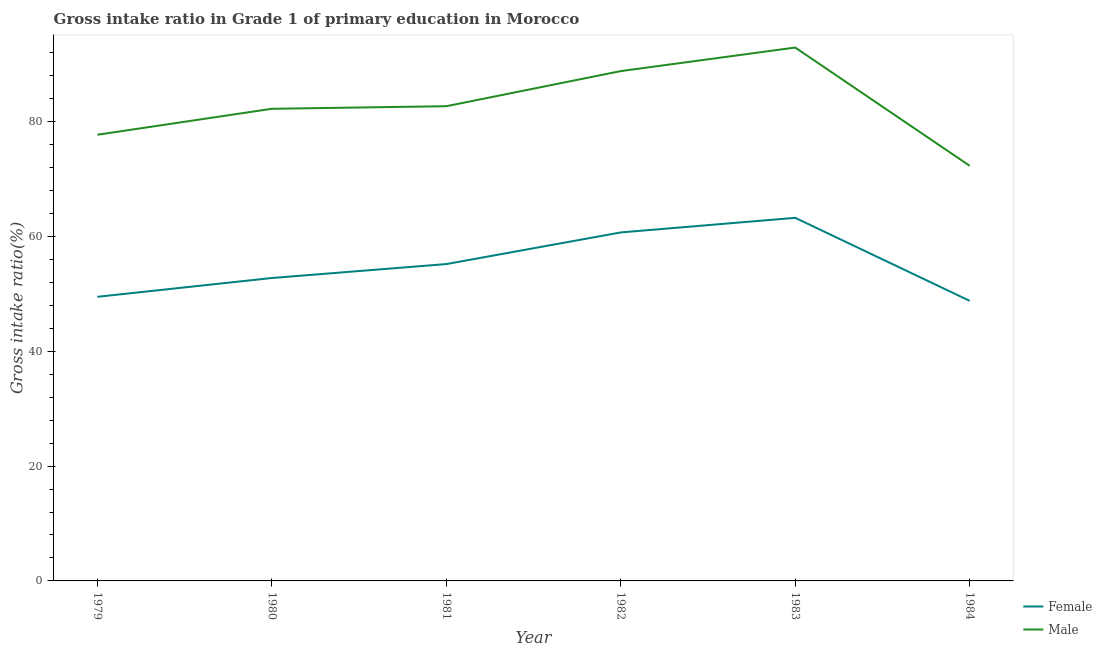Does the line corresponding to gross intake ratio(female) intersect with the line corresponding to gross intake ratio(male)?
Ensure brevity in your answer.  No. Is the number of lines equal to the number of legend labels?
Your answer should be very brief. Yes. What is the gross intake ratio(male) in 1983?
Provide a succinct answer. 92.88. Across all years, what is the maximum gross intake ratio(female)?
Make the answer very short. 63.23. Across all years, what is the minimum gross intake ratio(male)?
Your answer should be very brief. 72.29. In which year was the gross intake ratio(male) maximum?
Ensure brevity in your answer.  1983. In which year was the gross intake ratio(female) minimum?
Make the answer very short. 1984. What is the total gross intake ratio(male) in the graph?
Offer a terse response. 496.53. What is the difference between the gross intake ratio(female) in 1979 and that in 1981?
Your response must be concise. -5.7. What is the difference between the gross intake ratio(female) in 1981 and the gross intake ratio(male) in 1982?
Make the answer very short. -33.6. What is the average gross intake ratio(male) per year?
Provide a short and direct response. 82.76. In the year 1979, what is the difference between the gross intake ratio(female) and gross intake ratio(male)?
Offer a very short reply. -28.22. What is the ratio of the gross intake ratio(male) in 1979 to that in 1981?
Keep it short and to the point. 0.94. Is the difference between the gross intake ratio(male) in 1982 and 1984 greater than the difference between the gross intake ratio(female) in 1982 and 1984?
Your answer should be compact. Yes. What is the difference between the highest and the second highest gross intake ratio(female)?
Your answer should be very brief. 2.54. What is the difference between the highest and the lowest gross intake ratio(female)?
Offer a very short reply. 14.46. Does the gross intake ratio(female) monotonically increase over the years?
Offer a very short reply. No. Is the gross intake ratio(male) strictly greater than the gross intake ratio(female) over the years?
Offer a terse response. Yes. How many lines are there?
Your answer should be compact. 2. How many years are there in the graph?
Provide a short and direct response. 6. Are the values on the major ticks of Y-axis written in scientific E-notation?
Your answer should be compact. No. Does the graph contain any zero values?
Make the answer very short. No. Does the graph contain grids?
Offer a very short reply. No. Where does the legend appear in the graph?
Offer a terse response. Bottom right. How many legend labels are there?
Your response must be concise. 2. How are the legend labels stacked?
Offer a very short reply. Vertical. What is the title of the graph?
Offer a very short reply. Gross intake ratio in Grade 1 of primary education in Morocco. Does "% of gross capital formation" appear as one of the legend labels in the graph?
Provide a succinct answer. No. What is the label or title of the X-axis?
Offer a very short reply. Year. What is the label or title of the Y-axis?
Offer a terse response. Gross intake ratio(%). What is the Gross intake ratio(%) in Female in 1979?
Ensure brevity in your answer.  49.48. What is the Gross intake ratio(%) in Male in 1979?
Keep it short and to the point. 77.7. What is the Gross intake ratio(%) in Female in 1980?
Give a very brief answer. 52.75. What is the Gross intake ratio(%) of Male in 1980?
Give a very brief answer. 82.22. What is the Gross intake ratio(%) in Female in 1981?
Offer a terse response. 55.18. What is the Gross intake ratio(%) in Male in 1981?
Keep it short and to the point. 82.67. What is the Gross intake ratio(%) in Female in 1982?
Your answer should be very brief. 60.69. What is the Gross intake ratio(%) in Male in 1982?
Your answer should be compact. 88.78. What is the Gross intake ratio(%) in Female in 1983?
Your response must be concise. 63.23. What is the Gross intake ratio(%) in Male in 1983?
Keep it short and to the point. 92.88. What is the Gross intake ratio(%) in Female in 1984?
Ensure brevity in your answer.  48.77. What is the Gross intake ratio(%) of Male in 1984?
Offer a very short reply. 72.29. Across all years, what is the maximum Gross intake ratio(%) of Female?
Provide a succinct answer. 63.23. Across all years, what is the maximum Gross intake ratio(%) in Male?
Give a very brief answer. 92.88. Across all years, what is the minimum Gross intake ratio(%) of Female?
Provide a succinct answer. 48.77. Across all years, what is the minimum Gross intake ratio(%) in Male?
Provide a succinct answer. 72.29. What is the total Gross intake ratio(%) in Female in the graph?
Provide a short and direct response. 330.09. What is the total Gross intake ratio(%) in Male in the graph?
Provide a succinct answer. 496.53. What is the difference between the Gross intake ratio(%) in Female in 1979 and that in 1980?
Offer a very short reply. -3.27. What is the difference between the Gross intake ratio(%) of Male in 1979 and that in 1980?
Ensure brevity in your answer.  -4.52. What is the difference between the Gross intake ratio(%) of Female in 1979 and that in 1981?
Keep it short and to the point. -5.7. What is the difference between the Gross intake ratio(%) in Male in 1979 and that in 1981?
Your response must be concise. -4.97. What is the difference between the Gross intake ratio(%) of Female in 1979 and that in 1982?
Your answer should be very brief. -11.21. What is the difference between the Gross intake ratio(%) in Male in 1979 and that in 1982?
Your answer should be compact. -11.09. What is the difference between the Gross intake ratio(%) of Female in 1979 and that in 1983?
Provide a succinct answer. -13.75. What is the difference between the Gross intake ratio(%) of Male in 1979 and that in 1983?
Make the answer very short. -15.19. What is the difference between the Gross intake ratio(%) in Female in 1979 and that in 1984?
Your answer should be very brief. 0.71. What is the difference between the Gross intake ratio(%) in Male in 1979 and that in 1984?
Provide a succinct answer. 5.4. What is the difference between the Gross intake ratio(%) in Female in 1980 and that in 1981?
Keep it short and to the point. -2.43. What is the difference between the Gross intake ratio(%) in Male in 1980 and that in 1981?
Offer a terse response. -0.45. What is the difference between the Gross intake ratio(%) in Female in 1980 and that in 1982?
Your response must be concise. -7.94. What is the difference between the Gross intake ratio(%) in Male in 1980 and that in 1982?
Provide a short and direct response. -6.56. What is the difference between the Gross intake ratio(%) in Female in 1980 and that in 1983?
Your answer should be compact. -10.48. What is the difference between the Gross intake ratio(%) in Male in 1980 and that in 1983?
Ensure brevity in your answer.  -10.67. What is the difference between the Gross intake ratio(%) in Female in 1980 and that in 1984?
Provide a short and direct response. 3.98. What is the difference between the Gross intake ratio(%) in Male in 1980 and that in 1984?
Your answer should be compact. 9.93. What is the difference between the Gross intake ratio(%) of Female in 1981 and that in 1982?
Keep it short and to the point. -5.51. What is the difference between the Gross intake ratio(%) of Male in 1981 and that in 1982?
Offer a terse response. -6.11. What is the difference between the Gross intake ratio(%) in Female in 1981 and that in 1983?
Your answer should be compact. -8.05. What is the difference between the Gross intake ratio(%) in Male in 1981 and that in 1983?
Provide a succinct answer. -10.22. What is the difference between the Gross intake ratio(%) of Female in 1981 and that in 1984?
Your response must be concise. 6.41. What is the difference between the Gross intake ratio(%) of Male in 1981 and that in 1984?
Provide a succinct answer. 10.38. What is the difference between the Gross intake ratio(%) in Female in 1982 and that in 1983?
Give a very brief answer. -2.54. What is the difference between the Gross intake ratio(%) of Male in 1982 and that in 1983?
Your answer should be very brief. -4.1. What is the difference between the Gross intake ratio(%) of Female in 1982 and that in 1984?
Your answer should be compact. 11.92. What is the difference between the Gross intake ratio(%) of Male in 1982 and that in 1984?
Provide a succinct answer. 16.49. What is the difference between the Gross intake ratio(%) in Female in 1983 and that in 1984?
Provide a succinct answer. 14.46. What is the difference between the Gross intake ratio(%) in Male in 1983 and that in 1984?
Make the answer very short. 20.59. What is the difference between the Gross intake ratio(%) of Female in 1979 and the Gross intake ratio(%) of Male in 1980?
Keep it short and to the point. -32.74. What is the difference between the Gross intake ratio(%) of Female in 1979 and the Gross intake ratio(%) of Male in 1981?
Offer a terse response. -33.19. What is the difference between the Gross intake ratio(%) of Female in 1979 and the Gross intake ratio(%) of Male in 1982?
Make the answer very short. -39.3. What is the difference between the Gross intake ratio(%) of Female in 1979 and the Gross intake ratio(%) of Male in 1983?
Offer a very short reply. -43.41. What is the difference between the Gross intake ratio(%) of Female in 1979 and the Gross intake ratio(%) of Male in 1984?
Give a very brief answer. -22.81. What is the difference between the Gross intake ratio(%) of Female in 1980 and the Gross intake ratio(%) of Male in 1981?
Provide a short and direct response. -29.92. What is the difference between the Gross intake ratio(%) in Female in 1980 and the Gross intake ratio(%) in Male in 1982?
Your response must be concise. -36.03. What is the difference between the Gross intake ratio(%) of Female in 1980 and the Gross intake ratio(%) of Male in 1983?
Your answer should be very brief. -40.13. What is the difference between the Gross intake ratio(%) of Female in 1980 and the Gross intake ratio(%) of Male in 1984?
Offer a terse response. -19.54. What is the difference between the Gross intake ratio(%) in Female in 1981 and the Gross intake ratio(%) in Male in 1982?
Give a very brief answer. -33.6. What is the difference between the Gross intake ratio(%) of Female in 1981 and the Gross intake ratio(%) of Male in 1983?
Keep it short and to the point. -37.71. What is the difference between the Gross intake ratio(%) of Female in 1981 and the Gross intake ratio(%) of Male in 1984?
Provide a succinct answer. -17.11. What is the difference between the Gross intake ratio(%) of Female in 1982 and the Gross intake ratio(%) of Male in 1983?
Keep it short and to the point. -32.2. What is the difference between the Gross intake ratio(%) of Female in 1982 and the Gross intake ratio(%) of Male in 1984?
Offer a terse response. -11.6. What is the difference between the Gross intake ratio(%) in Female in 1983 and the Gross intake ratio(%) in Male in 1984?
Make the answer very short. -9.06. What is the average Gross intake ratio(%) of Female per year?
Your response must be concise. 55.01. What is the average Gross intake ratio(%) of Male per year?
Make the answer very short. 82.76. In the year 1979, what is the difference between the Gross intake ratio(%) in Female and Gross intake ratio(%) in Male?
Ensure brevity in your answer.  -28.22. In the year 1980, what is the difference between the Gross intake ratio(%) in Female and Gross intake ratio(%) in Male?
Keep it short and to the point. -29.47. In the year 1981, what is the difference between the Gross intake ratio(%) of Female and Gross intake ratio(%) of Male?
Your answer should be very brief. -27.49. In the year 1982, what is the difference between the Gross intake ratio(%) in Female and Gross intake ratio(%) in Male?
Ensure brevity in your answer.  -28.1. In the year 1983, what is the difference between the Gross intake ratio(%) in Female and Gross intake ratio(%) in Male?
Provide a short and direct response. -29.66. In the year 1984, what is the difference between the Gross intake ratio(%) of Female and Gross intake ratio(%) of Male?
Your answer should be very brief. -23.52. What is the ratio of the Gross intake ratio(%) in Female in 1979 to that in 1980?
Keep it short and to the point. 0.94. What is the ratio of the Gross intake ratio(%) in Male in 1979 to that in 1980?
Keep it short and to the point. 0.94. What is the ratio of the Gross intake ratio(%) in Female in 1979 to that in 1981?
Keep it short and to the point. 0.9. What is the ratio of the Gross intake ratio(%) in Male in 1979 to that in 1981?
Your response must be concise. 0.94. What is the ratio of the Gross intake ratio(%) of Female in 1979 to that in 1982?
Provide a succinct answer. 0.82. What is the ratio of the Gross intake ratio(%) of Male in 1979 to that in 1982?
Ensure brevity in your answer.  0.88. What is the ratio of the Gross intake ratio(%) of Female in 1979 to that in 1983?
Offer a terse response. 0.78. What is the ratio of the Gross intake ratio(%) of Male in 1979 to that in 1983?
Offer a terse response. 0.84. What is the ratio of the Gross intake ratio(%) of Female in 1979 to that in 1984?
Give a very brief answer. 1.01. What is the ratio of the Gross intake ratio(%) in Male in 1979 to that in 1984?
Give a very brief answer. 1.07. What is the ratio of the Gross intake ratio(%) of Female in 1980 to that in 1981?
Your response must be concise. 0.96. What is the ratio of the Gross intake ratio(%) of Female in 1980 to that in 1982?
Your answer should be very brief. 0.87. What is the ratio of the Gross intake ratio(%) of Male in 1980 to that in 1982?
Your response must be concise. 0.93. What is the ratio of the Gross intake ratio(%) in Female in 1980 to that in 1983?
Provide a succinct answer. 0.83. What is the ratio of the Gross intake ratio(%) of Male in 1980 to that in 1983?
Provide a succinct answer. 0.89. What is the ratio of the Gross intake ratio(%) of Female in 1980 to that in 1984?
Make the answer very short. 1.08. What is the ratio of the Gross intake ratio(%) of Male in 1980 to that in 1984?
Your answer should be compact. 1.14. What is the ratio of the Gross intake ratio(%) in Female in 1981 to that in 1982?
Your answer should be compact. 0.91. What is the ratio of the Gross intake ratio(%) of Male in 1981 to that in 1982?
Your answer should be very brief. 0.93. What is the ratio of the Gross intake ratio(%) in Female in 1981 to that in 1983?
Make the answer very short. 0.87. What is the ratio of the Gross intake ratio(%) of Male in 1981 to that in 1983?
Your answer should be compact. 0.89. What is the ratio of the Gross intake ratio(%) of Female in 1981 to that in 1984?
Your answer should be compact. 1.13. What is the ratio of the Gross intake ratio(%) in Male in 1981 to that in 1984?
Give a very brief answer. 1.14. What is the ratio of the Gross intake ratio(%) in Female in 1982 to that in 1983?
Keep it short and to the point. 0.96. What is the ratio of the Gross intake ratio(%) in Male in 1982 to that in 1983?
Your answer should be compact. 0.96. What is the ratio of the Gross intake ratio(%) of Female in 1982 to that in 1984?
Give a very brief answer. 1.24. What is the ratio of the Gross intake ratio(%) in Male in 1982 to that in 1984?
Your answer should be very brief. 1.23. What is the ratio of the Gross intake ratio(%) in Female in 1983 to that in 1984?
Provide a succinct answer. 1.3. What is the ratio of the Gross intake ratio(%) in Male in 1983 to that in 1984?
Offer a very short reply. 1.28. What is the difference between the highest and the second highest Gross intake ratio(%) in Female?
Offer a terse response. 2.54. What is the difference between the highest and the second highest Gross intake ratio(%) of Male?
Give a very brief answer. 4.1. What is the difference between the highest and the lowest Gross intake ratio(%) of Female?
Provide a short and direct response. 14.46. What is the difference between the highest and the lowest Gross intake ratio(%) in Male?
Ensure brevity in your answer.  20.59. 